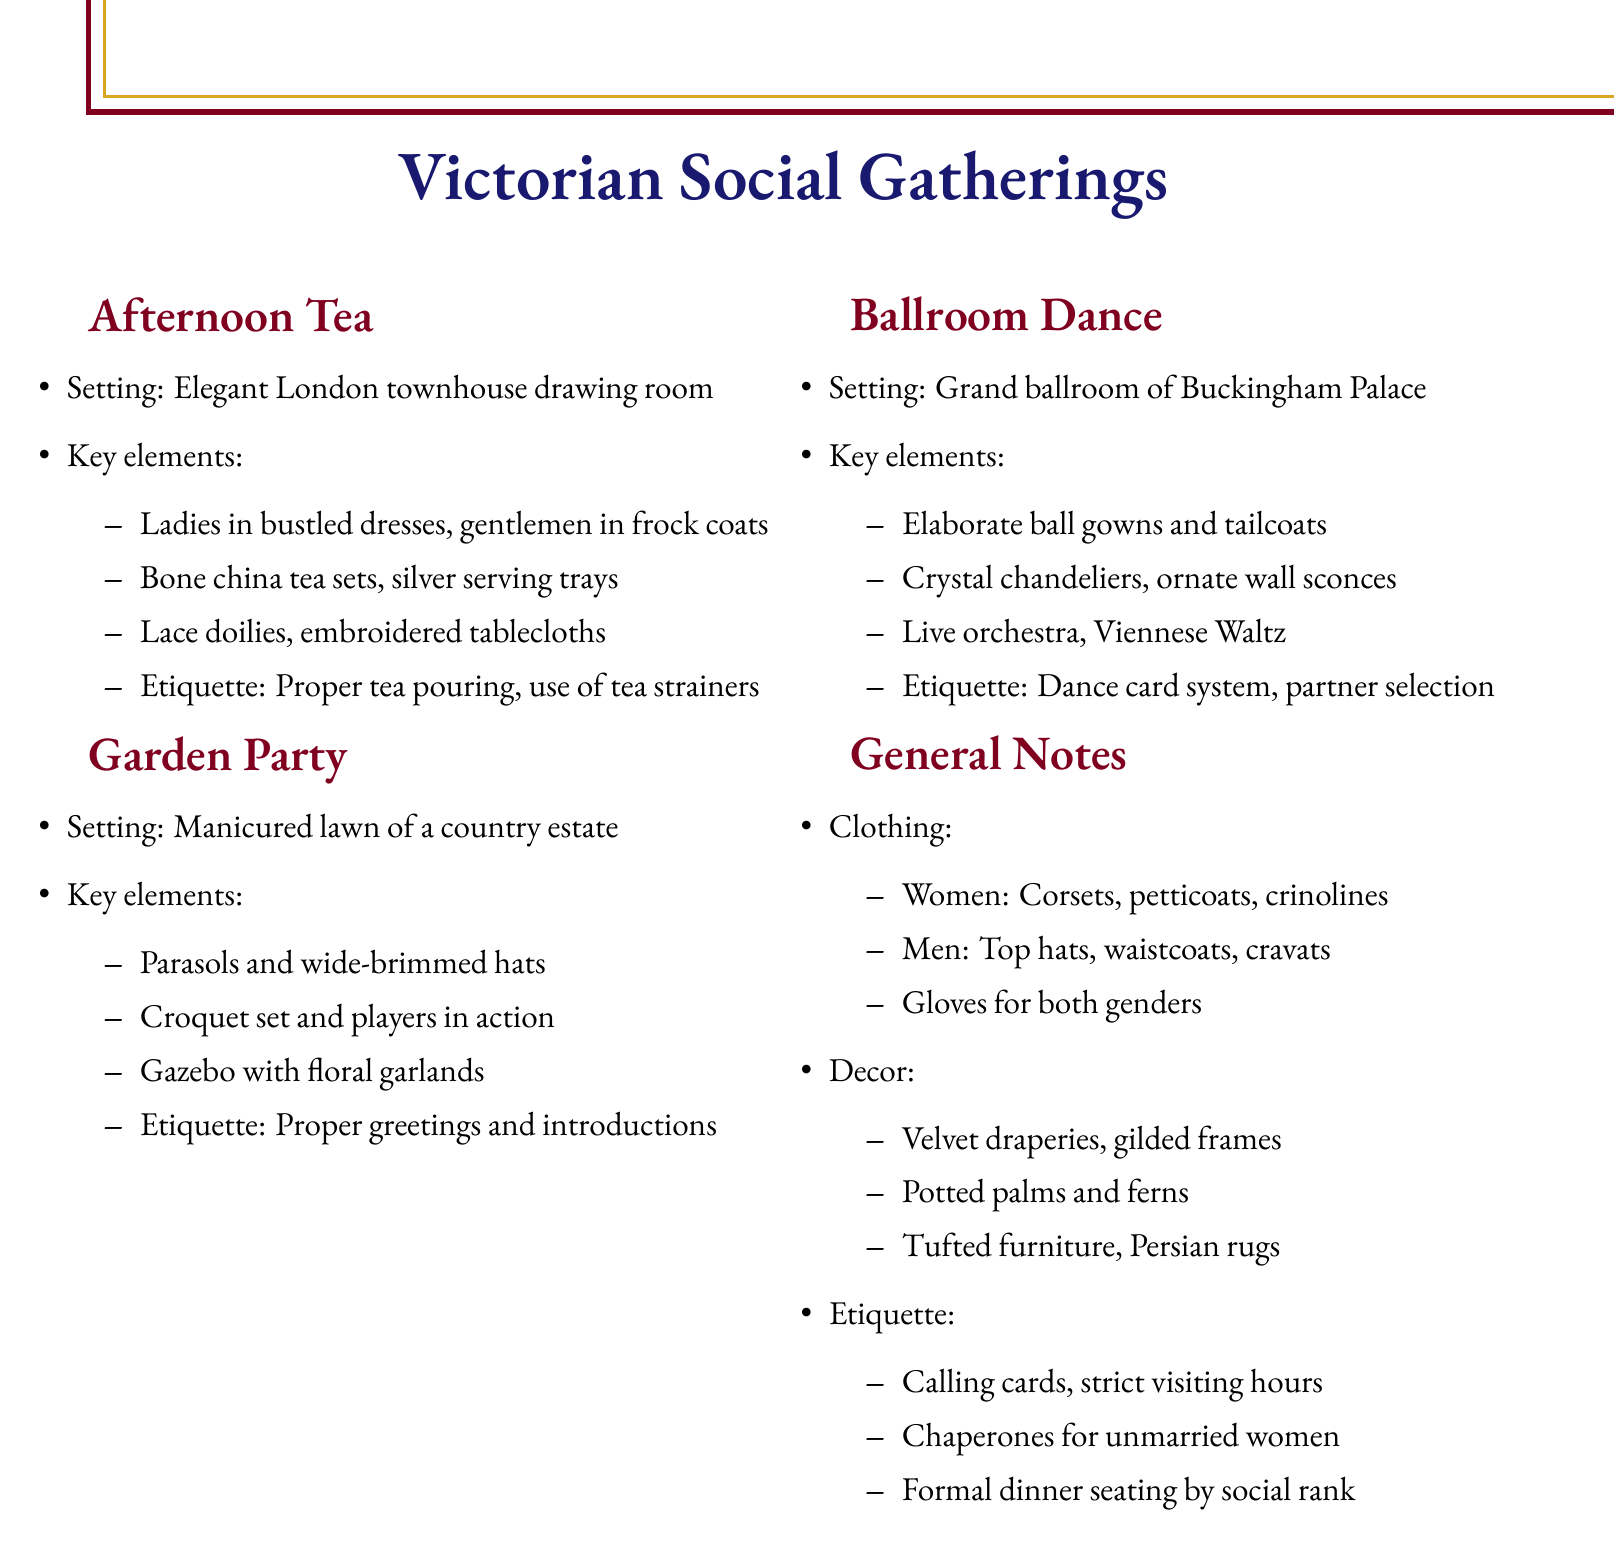What is the theme of the first gathering? The theme is stated at the beginning of the section for the first gathering.
Answer: Afternoon Tea Where is the setting for the Garden Party? The setting is mentioned in the notes for the Garden Party section.
Answer: Manicured lawn of a country estate What do women typically wear at a ballroom dance? The specific clothing details for women at the ballroom dance are provided in the general notes section.
Answer: Elaborate ball gowns What is one key decor element for the Afternoon Tea? The key elements section lists important decor features specifically for the Afternoon Tea.
Answer: Lace doilies What is the etiquette associated with the Garden Party? The etiquette notes for the Garden Party are explicitly given in the notes section for that theme.
Answer: Proper greetings and introductions What type of dance is performed at the ballroom? The type of dance is specified in the key elements for the ballroom dance section.
Answer: Viennese Waltz What accessory is essential for both genders during these gatherings? The general notes on clothing highlight accessories important for both genders.
Answer: Gloves What type of furniture is mentioned in the decor elements? The decor elements section lists specific types of furniture relevant to the gatherings.
Answer: Tufted furniture 